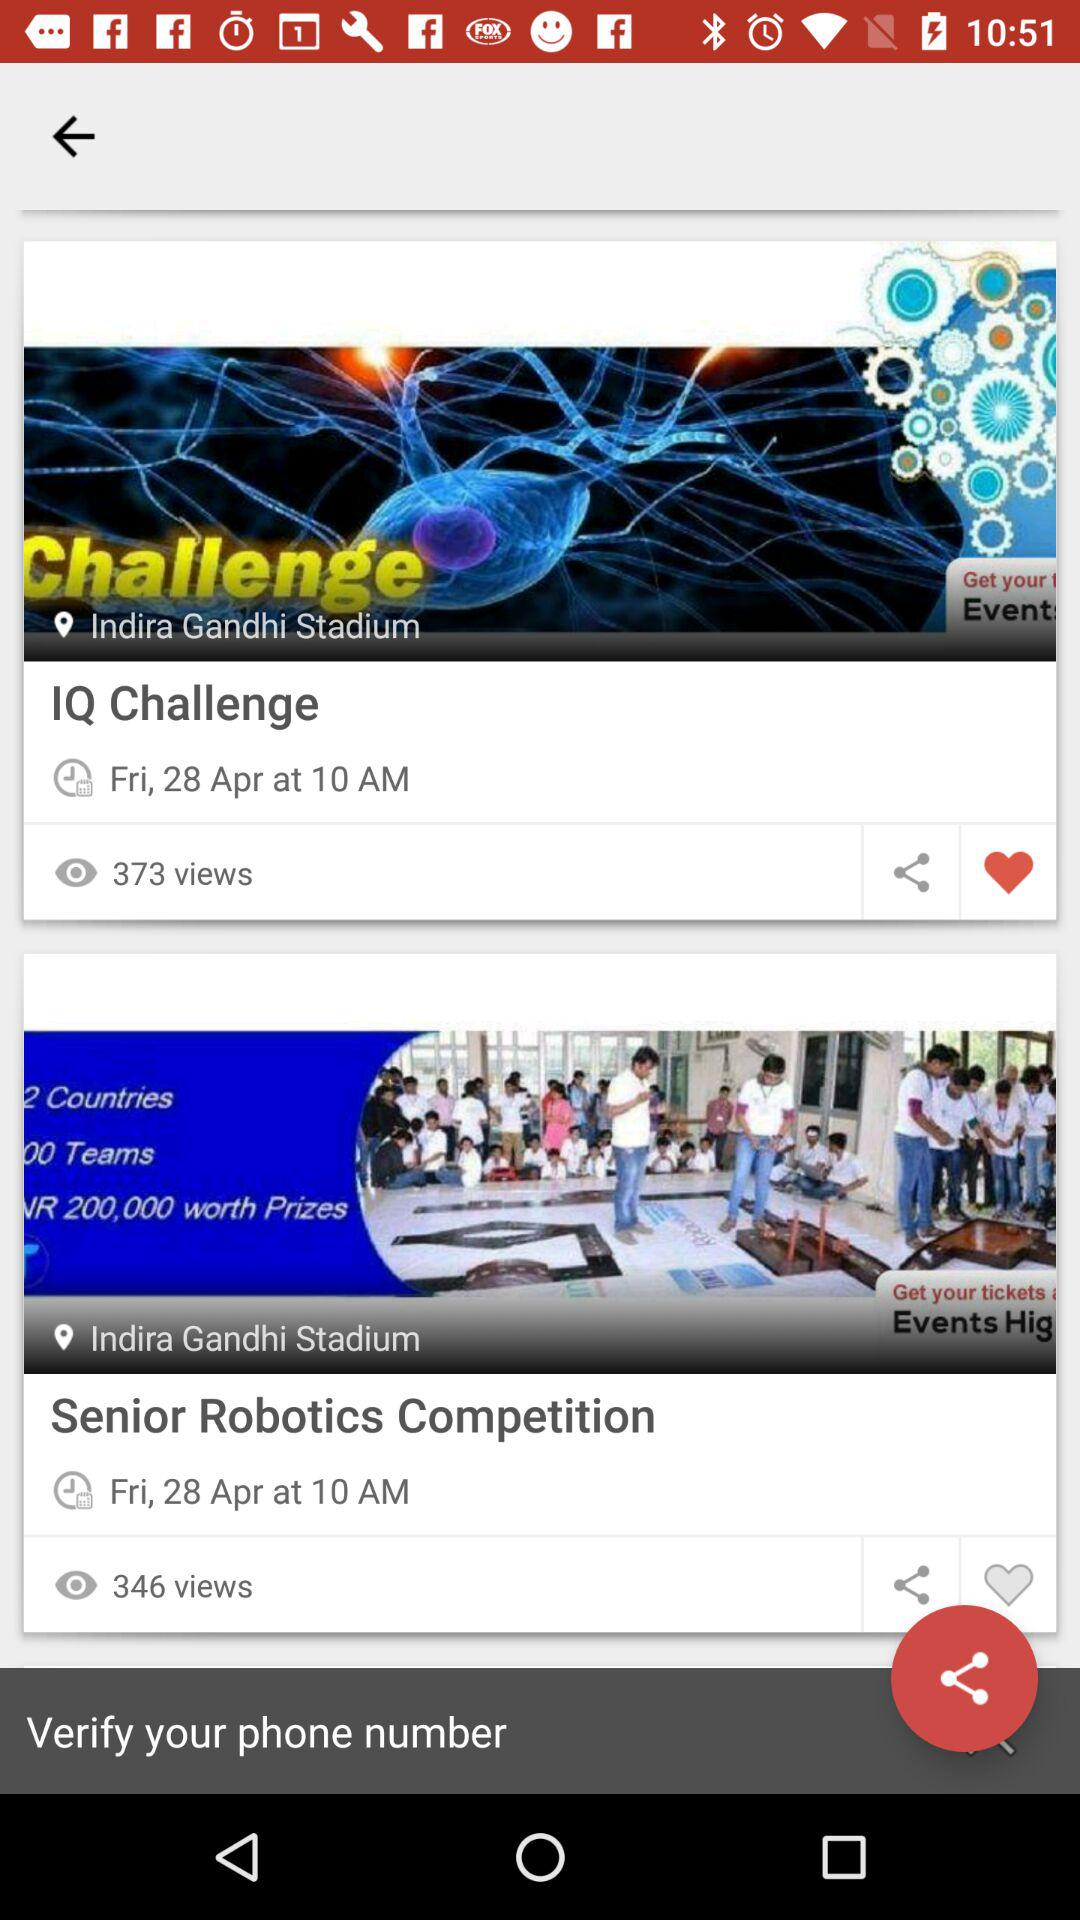How many people have watched the "Senior Robotics Competition"? It is watched by 346 people. 